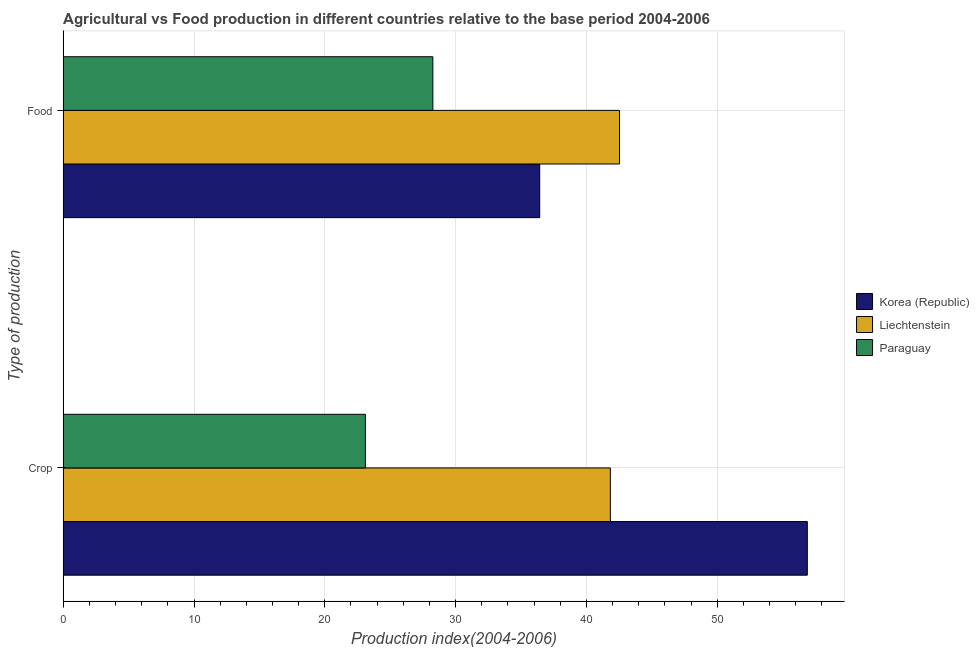How many different coloured bars are there?
Give a very brief answer. 3. Are the number of bars per tick equal to the number of legend labels?
Ensure brevity in your answer.  Yes. Are the number of bars on each tick of the Y-axis equal?
Offer a very short reply. Yes. How many bars are there on the 1st tick from the top?
Ensure brevity in your answer.  3. What is the label of the 2nd group of bars from the top?
Your answer should be compact. Crop. What is the crop production index in Paraguay?
Offer a very short reply. 23.1. Across all countries, what is the maximum crop production index?
Your answer should be compact. 56.89. Across all countries, what is the minimum food production index?
Keep it short and to the point. 28.26. In which country was the crop production index minimum?
Offer a very short reply. Paraguay. What is the total crop production index in the graph?
Offer a very short reply. 121.82. What is the difference between the food production index in Liechtenstein and that in Paraguay?
Your answer should be very brief. 14.27. What is the difference between the food production index in Korea (Republic) and the crop production index in Paraguay?
Offer a terse response. 13.33. What is the average food production index per country?
Your response must be concise. 35.74. What is the difference between the crop production index and food production index in Korea (Republic)?
Your response must be concise. 20.46. What is the ratio of the food production index in Korea (Republic) to that in Paraguay?
Make the answer very short. 1.29. Is the food production index in Liechtenstein less than that in Korea (Republic)?
Keep it short and to the point. No. In how many countries, is the crop production index greater than the average crop production index taken over all countries?
Keep it short and to the point. 2. What does the 1st bar from the top in Crop represents?
Keep it short and to the point. Paraguay. How many bars are there?
Your answer should be compact. 6. Are all the bars in the graph horizontal?
Ensure brevity in your answer.  Yes. Does the graph contain any zero values?
Provide a succinct answer. No. Does the graph contain grids?
Your answer should be very brief. Yes. How many legend labels are there?
Provide a short and direct response. 3. What is the title of the graph?
Offer a terse response. Agricultural vs Food production in different countries relative to the base period 2004-2006. What is the label or title of the X-axis?
Provide a succinct answer. Production index(2004-2006). What is the label or title of the Y-axis?
Offer a very short reply. Type of production. What is the Production index(2004-2006) in Korea (Republic) in Crop?
Ensure brevity in your answer.  56.89. What is the Production index(2004-2006) of Liechtenstein in Crop?
Ensure brevity in your answer.  41.83. What is the Production index(2004-2006) in Paraguay in Crop?
Offer a very short reply. 23.1. What is the Production index(2004-2006) of Korea (Republic) in Food?
Ensure brevity in your answer.  36.43. What is the Production index(2004-2006) of Liechtenstein in Food?
Your answer should be compact. 42.53. What is the Production index(2004-2006) in Paraguay in Food?
Keep it short and to the point. 28.26. Across all Type of production, what is the maximum Production index(2004-2006) of Korea (Republic)?
Ensure brevity in your answer.  56.89. Across all Type of production, what is the maximum Production index(2004-2006) in Liechtenstein?
Offer a terse response. 42.53. Across all Type of production, what is the maximum Production index(2004-2006) in Paraguay?
Offer a terse response. 28.26. Across all Type of production, what is the minimum Production index(2004-2006) of Korea (Republic)?
Offer a very short reply. 36.43. Across all Type of production, what is the minimum Production index(2004-2006) in Liechtenstein?
Your answer should be very brief. 41.83. Across all Type of production, what is the minimum Production index(2004-2006) of Paraguay?
Ensure brevity in your answer.  23.1. What is the total Production index(2004-2006) in Korea (Republic) in the graph?
Offer a very short reply. 93.32. What is the total Production index(2004-2006) in Liechtenstein in the graph?
Provide a succinct answer. 84.36. What is the total Production index(2004-2006) of Paraguay in the graph?
Your answer should be very brief. 51.36. What is the difference between the Production index(2004-2006) in Korea (Republic) in Crop and that in Food?
Provide a short and direct response. 20.46. What is the difference between the Production index(2004-2006) in Liechtenstein in Crop and that in Food?
Your answer should be very brief. -0.7. What is the difference between the Production index(2004-2006) of Paraguay in Crop and that in Food?
Offer a very short reply. -5.16. What is the difference between the Production index(2004-2006) of Korea (Republic) in Crop and the Production index(2004-2006) of Liechtenstein in Food?
Ensure brevity in your answer.  14.36. What is the difference between the Production index(2004-2006) of Korea (Republic) in Crop and the Production index(2004-2006) of Paraguay in Food?
Provide a short and direct response. 28.63. What is the difference between the Production index(2004-2006) of Liechtenstein in Crop and the Production index(2004-2006) of Paraguay in Food?
Your answer should be very brief. 13.57. What is the average Production index(2004-2006) in Korea (Republic) per Type of production?
Your answer should be compact. 46.66. What is the average Production index(2004-2006) of Liechtenstein per Type of production?
Keep it short and to the point. 42.18. What is the average Production index(2004-2006) in Paraguay per Type of production?
Your answer should be compact. 25.68. What is the difference between the Production index(2004-2006) in Korea (Republic) and Production index(2004-2006) in Liechtenstein in Crop?
Ensure brevity in your answer.  15.06. What is the difference between the Production index(2004-2006) of Korea (Republic) and Production index(2004-2006) of Paraguay in Crop?
Keep it short and to the point. 33.79. What is the difference between the Production index(2004-2006) in Liechtenstein and Production index(2004-2006) in Paraguay in Crop?
Your response must be concise. 18.73. What is the difference between the Production index(2004-2006) of Korea (Republic) and Production index(2004-2006) of Liechtenstein in Food?
Offer a terse response. -6.1. What is the difference between the Production index(2004-2006) in Korea (Republic) and Production index(2004-2006) in Paraguay in Food?
Your answer should be very brief. 8.17. What is the difference between the Production index(2004-2006) of Liechtenstein and Production index(2004-2006) of Paraguay in Food?
Make the answer very short. 14.27. What is the ratio of the Production index(2004-2006) in Korea (Republic) in Crop to that in Food?
Your response must be concise. 1.56. What is the ratio of the Production index(2004-2006) of Liechtenstein in Crop to that in Food?
Your response must be concise. 0.98. What is the ratio of the Production index(2004-2006) of Paraguay in Crop to that in Food?
Give a very brief answer. 0.82. What is the difference between the highest and the second highest Production index(2004-2006) in Korea (Republic)?
Provide a short and direct response. 20.46. What is the difference between the highest and the second highest Production index(2004-2006) in Liechtenstein?
Make the answer very short. 0.7. What is the difference between the highest and the second highest Production index(2004-2006) in Paraguay?
Your answer should be very brief. 5.16. What is the difference between the highest and the lowest Production index(2004-2006) in Korea (Republic)?
Offer a very short reply. 20.46. What is the difference between the highest and the lowest Production index(2004-2006) of Paraguay?
Keep it short and to the point. 5.16. 